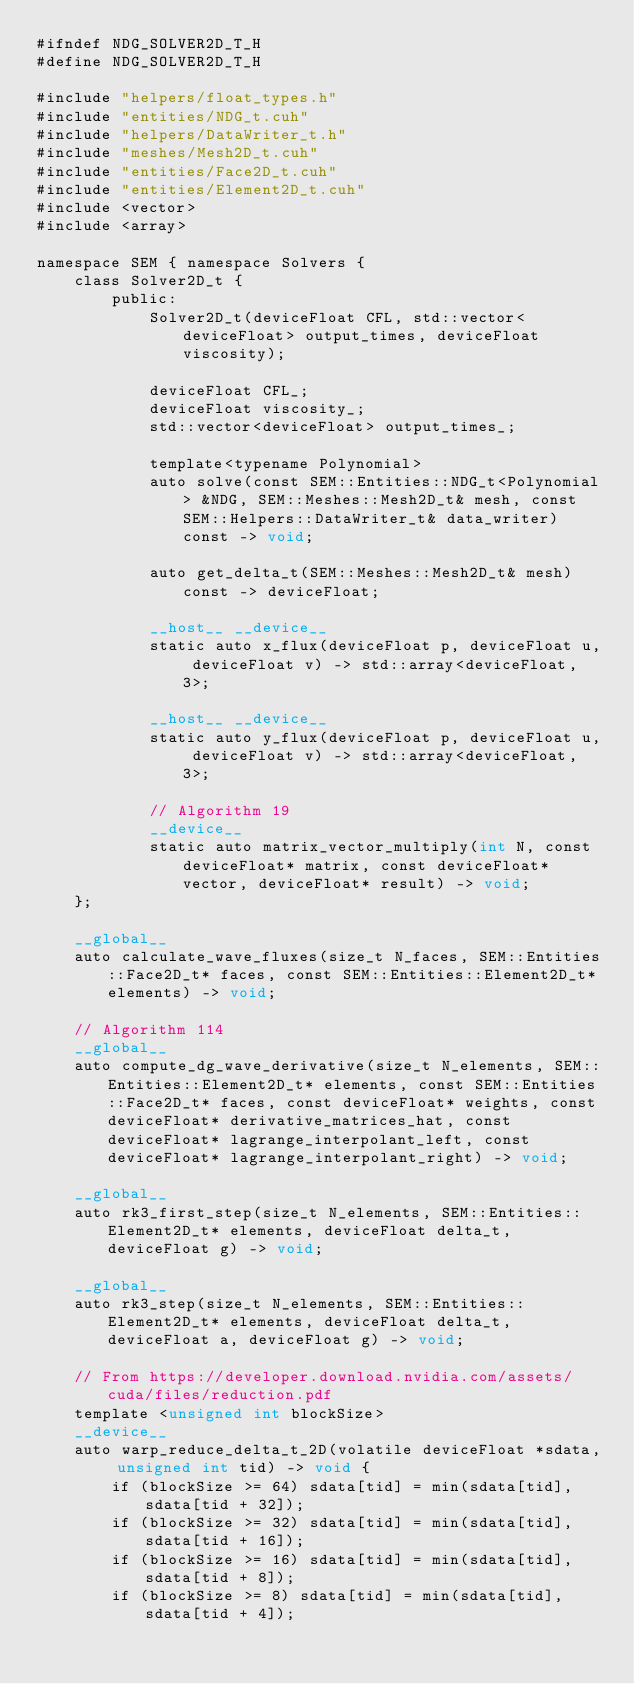<code> <loc_0><loc_0><loc_500><loc_500><_Cuda_>#ifndef NDG_SOLVER2D_T_H
#define NDG_SOLVER2D_T_H

#include "helpers/float_types.h"
#include "entities/NDG_t.cuh"
#include "helpers/DataWriter_t.h"
#include "meshes/Mesh2D_t.cuh"
#include "entities/Face2D_t.cuh"
#include "entities/Element2D_t.cuh"
#include <vector>
#include <array>

namespace SEM { namespace Solvers {
    class Solver2D_t {
        public:
            Solver2D_t(deviceFloat CFL, std::vector<deviceFloat> output_times, deviceFloat viscosity);

            deviceFloat CFL_;
            deviceFloat viscosity_;
            std::vector<deviceFloat> output_times_;

            template<typename Polynomial>
            auto solve(const SEM::Entities::NDG_t<Polynomial> &NDG, SEM::Meshes::Mesh2D_t& mesh, const SEM::Helpers::DataWriter_t& data_writer) const -> void;

            auto get_delta_t(SEM::Meshes::Mesh2D_t& mesh) const -> deviceFloat;

            __host__ __device__
            static auto x_flux(deviceFloat p, deviceFloat u, deviceFloat v) -> std::array<deviceFloat, 3>;

            __host__ __device__
            static auto y_flux(deviceFloat p, deviceFloat u, deviceFloat v) -> std::array<deviceFloat, 3>;

            // Algorithm 19
            __device__
            static auto matrix_vector_multiply(int N, const deviceFloat* matrix, const deviceFloat* vector, deviceFloat* result) -> void;
    };

    __global__
    auto calculate_wave_fluxes(size_t N_faces, SEM::Entities::Face2D_t* faces, const SEM::Entities::Element2D_t* elements) -> void;

    // Algorithm 114
    __global__
    auto compute_dg_wave_derivative(size_t N_elements, SEM::Entities::Element2D_t* elements, const SEM::Entities::Face2D_t* faces, const deviceFloat* weights, const deviceFloat* derivative_matrices_hat, const deviceFloat* lagrange_interpolant_left, const deviceFloat* lagrange_interpolant_right) -> void;

    __global__
    auto rk3_first_step(size_t N_elements, SEM::Entities::Element2D_t* elements, deviceFloat delta_t, deviceFloat g) -> void;

    __global__
    auto rk3_step(size_t N_elements, SEM::Entities::Element2D_t* elements, deviceFloat delta_t, deviceFloat a, deviceFloat g) -> void;

    // From https://developer.download.nvidia.com/assets/cuda/files/reduction.pdf
    template <unsigned int blockSize>
    __device__ 
    auto warp_reduce_delta_t_2D(volatile deviceFloat *sdata, unsigned int tid) -> void {
        if (blockSize >= 64) sdata[tid] = min(sdata[tid], sdata[tid + 32]);
        if (blockSize >= 32) sdata[tid] = min(sdata[tid], sdata[tid + 16]);
        if (blockSize >= 16) sdata[tid] = min(sdata[tid], sdata[tid + 8]);
        if (blockSize >= 8) sdata[tid] = min(sdata[tid], sdata[tid + 4]);</code> 